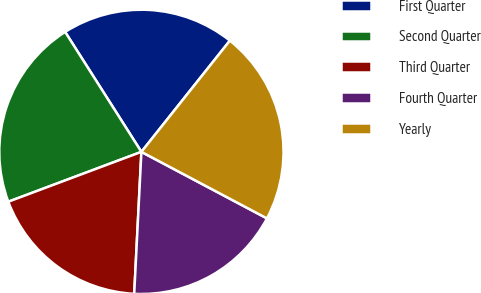Convert chart to OTSL. <chart><loc_0><loc_0><loc_500><loc_500><pie_chart><fcel>First Quarter<fcel>Second Quarter<fcel>Third Quarter<fcel>Fourth Quarter<fcel>Yearly<nl><fcel>19.71%<fcel>21.69%<fcel>18.49%<fcel>18.05%<fcel>22.06%<nl></chart> 